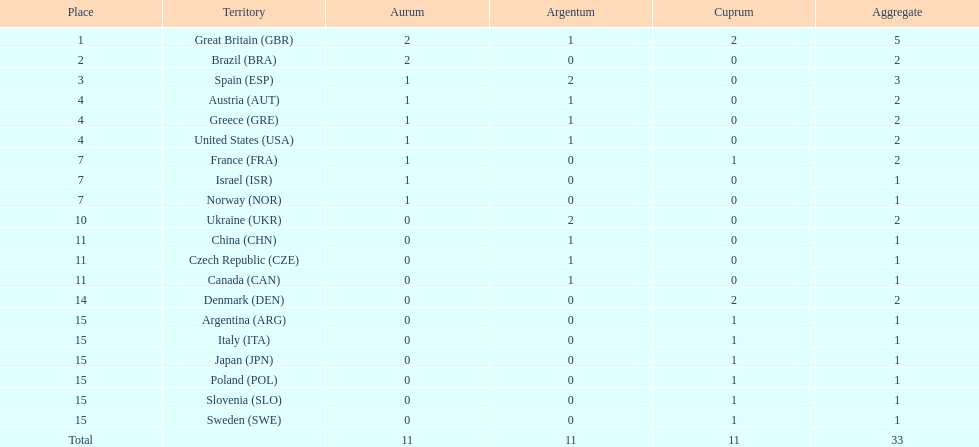What country had the most medals? Great Britain. 